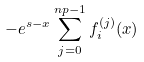<formula> <loc_0><loc_0><loc_500><loc_500>- e ^ { s - x } \sum _ { j = 0 } ^ { n p - 1 } f _ { i } ^ { ( j ) } ( x )</formula> 